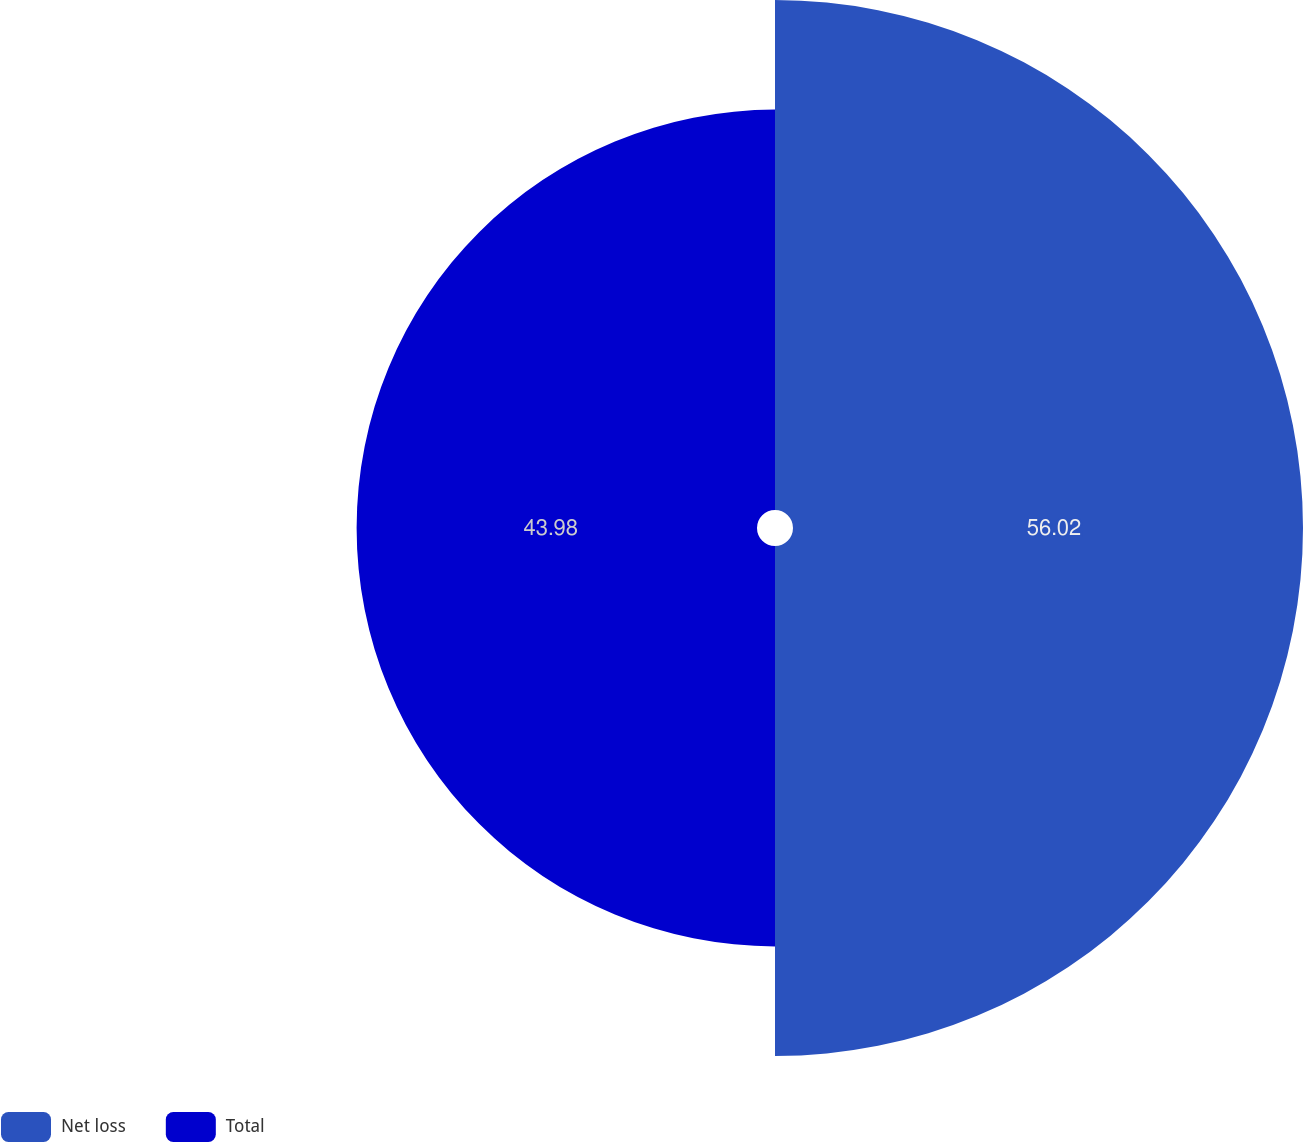<chart> <loc_0><loc_0><loc_500><loc_500><pie_chart><fcel>Net loss<fcel>Total<nl><fcel>56.02%<fcel>43.98%<nl></chart> 